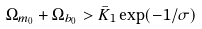Convert formula to latex. <formula><loc_0><loc_0><loc_500><loc_500>\Omega _ { m _ { 0 } } + \Omega _ { b _ { 0 } } > \bar { K } _ { 1 } \exp ( - 1 / \sigma )</formula> 